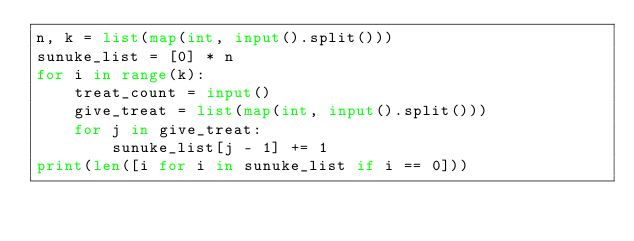<code> <loc_0><loc_0><loc_500><loc_500><_Python_>n, k = list(map(int, input().split()))
sunuke_list = [0] * n
for i in range(k):
    treat_count = input()
    give_treat = list(map(int, input().split()))
    for j in give_treat:
        sunuke_list[j - 1] += 1
print(len([i for i in sunuke_list if i == 0]))
</code> 